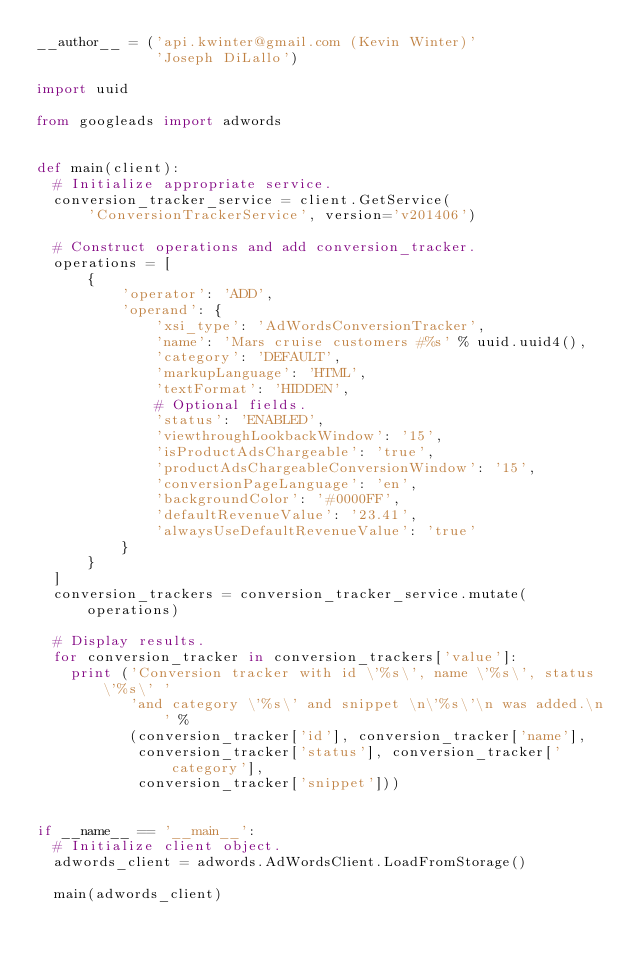<code> <loc_0><loc_0><loc_500><loc_500><_Python_>__author__ = ('api.kwinter@gmail.com (Kevin Winter)'
              'Joseph DiLallo')

import uuid

from googleads import adwords


def main(client):
  # Initialize appropriate service.
  conversion_tracker_service = client.GetService(
      'ConversionTrackerService', version='v201406')

  # Construct operations and add conversion_tracker.
  operations = [
      {
          'operator': 'ADD',
          'operand': {
              'xsi_type': 'AdWordsConversionTracker',
              'name': 'Mars cruise customers #%s' % uuid.uuid4(),
              'category': 'DEFAULT',
              'markupLanguage': 'HTML',
              'textFormat': 'HIDDEN',
              # Optional fields.
              'status': 'ENABLED',
              'viewthroughLookbackWindow': '15',
              'isProductAdsChargeable': 'true',
              'productAdsChargeableConversionWindow': '15',
              'conversionPageLanguage': 'en',
              'backgroundColor': '#0000FF',
              'defaultRevenueValue': '23.41',
              'alwaysUseDefaultRevenueValue': 'true'
          }
      }
  ]
  conversion_trackers = conversion_tracker_service.mutate(operations)

  # Display results.
  for conversion_tracker in conversion_trackers['value']:
    print ('Conversion tracker with id \'%s\', name \'%s\', status \'%s\' '
           'and category \'%s\' and snippet \n\'%s\'\n was added.\n' %
           (conversion_tracker['id'], conversion_tracker['name'],
            conversion_tracker['status'], conversion_tracker['category'],
            conversion_tracker['snippet']))


if __name__ == '__main__':
  # Initialize client object.
  adwords_client = adwords.AdWordsClient.LoadFromStorage()

  main(adwords_client)
</code> 